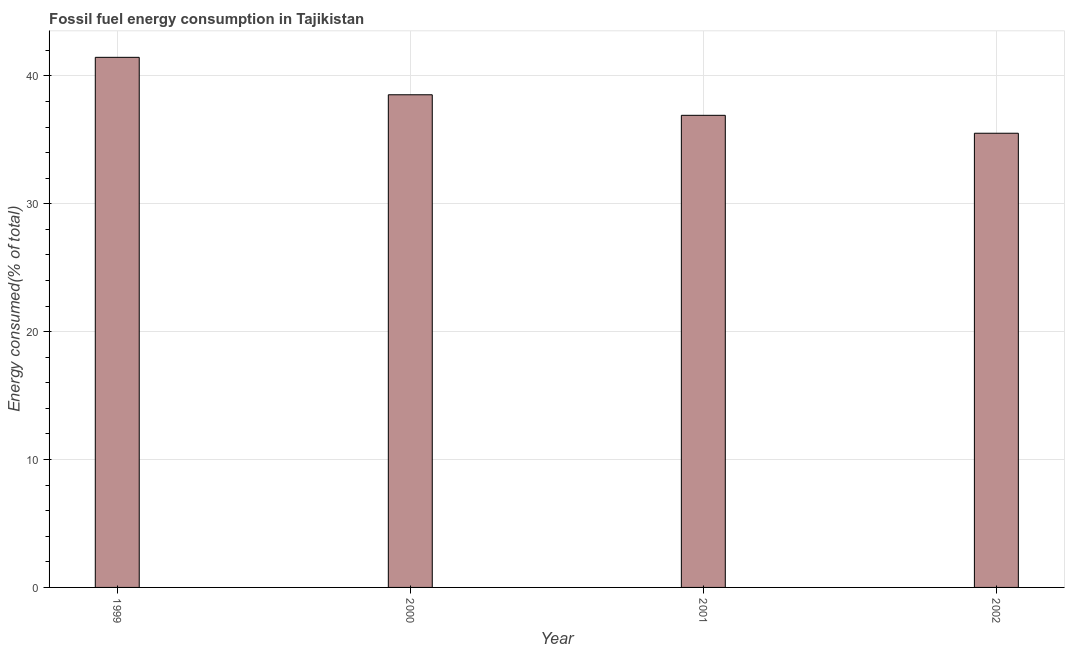Does the graph contain any zero values?
Make the answer very short. No. Does the graph contain grids?
Your answer should be compact. Yes. What is the title of the graph?
Provide a short and direct response. Fossil fuel energy consumption in Tajikistan. What is the label or title of the Y-axis?
Offer a terse response. Energy consumed(% of total). What is the fossil fuel energy consumption in 2002?
Provide a short and direct response. 35.52. Across all years, what is the maximum fossil fuel energy consumption?
Provide a succinct answer. 41.46. Across all years, what is the minimum fossil fuel energy consumption?
Make the answer very short. 35.52. In which year was the fossil fuel energy consumption maximum?
Ensure brevity in your answer.  1999. What is the sum of the fossil fuel energy consumption?
Keep it short and to the point. 152.43. What is the difference between the fossil fuel energy consumption in 1999 and 2000?
Make the answer very short. 2.93. What is the average fossil fuel energy consumption per year?
Keep it short and to the point. 38.11. What is the median fossil fuel energy consumption?
Your answer should be compact. 37.73. Do a majority of the years between 2002 and 2001 (inclusive) have fossil fuel energy consumption greater than 24 %?
Your answer should be compact. No. What is the ratio of the fossil fuel energy consumption in 2000 to that in 2002?
Your response must be concise. 1.08. Is the difference between the fossil fuel energy consumption in 1999 and 2001 greater than the difference between any two years?
Your response must be concise. No. What is the difference between the highest and the second highest fossil fuel energy consumption?
Provide a short and direct response. 2.93. What is the difference between the highest and the lowest fossil fuel energy consumption?
Your response must be concise. 5.94. How many years are there in the graph?
Give a very brief answer. 4. What is the difference between two consecutive major ticks on the Y-axis?
Provide a succinct answer. 10. What is the Energy consumed(% of total) in 1999?
Provide a succinct answer. 41.46. What is the Energy consumed(% of total) in 2000?
Your answer should be very brief. 38.53. What is the Energy consumed(% of total) in 2001?
Ensure brevity in your answer.  36.92. What is the Energy consumed(% of total) in 2002?
Your answer should be very brief. 35.52. What is the difference between the Energy consumed(% of total) in 1999 and 2000?
Provide a succinct answer. 2.93. What is the difference between the Energy consumed(% of total) in 1999 and 2001?
Make the answer very short. 4.53. What is the difference between the Energy consumed(% of total) in 1999 and 2002?
Offer a terse response. 5.94. What is the difference between the Energy consumed(% of total) in 2000 and 2001?
Make the answer very short. 1.61. What is the difference between the Energy consumed(% of total) in 2000 and 2002?
Provide a short and direct response. 3.01. What is the difference between the Energy consumed(% of total) in 2001 and 2002?
Your response must be concise. 1.4. What is the ratio of the Energy consumed(% of total) in 1999 to that in 2000?
Provide a short and direct response. 1.08. What is the ratio of the Energy consumed(% of total) in 1999 to that in 2001?
Offer a terse response. 1.12. What is the ratio of the Energy consumed(% of total) in 1999 to that in 2002?
Offer a very short reply. 1.17. What is the ratio of the Energy consumed(% of total) in 2000 to that in 2001?
Provide a short and direct response. 1.04. What is the ratio of the Energy consumed(% of total) in 2000 to that in 2002?
Keep it short and to the point. 1.08. What is the ratio of the Energy consumed(% of total) in 2001 to that in 2002?
Offer a very short reply. 1.04. 